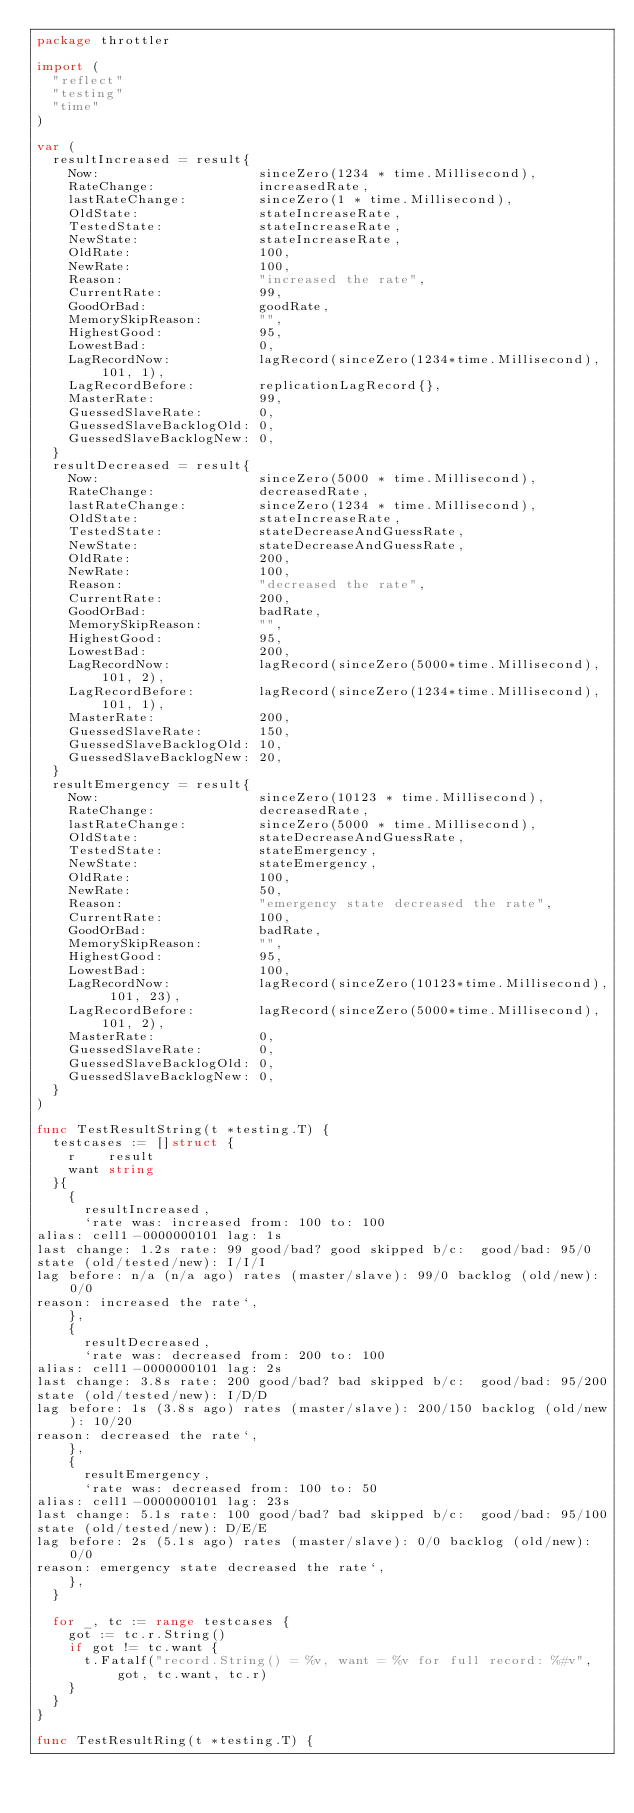<code> <loc_0><loc_0><loc_500><loc_500><_Go_>package throttler

import (
	"reflect"
	"testing"
	"time"
)

var (
	resultIncreased = result{
		Now:                    sinceZero(1234 * time.Millisecond),
		RateChange:             increasedRate,
		lastRateChange:         sinceZero(1 * time.Millisecond),
		OldState:               stateIncreaseRate,
		TestedState:            stateIncreaseRate,
		NewState:               stateIncreaseRate,
		OldRate:                100,
		NewRate:                100,
		Reason:                 "increased the rate",
		CurrentRate:            99,
		GoodOrBad:              goodRate,
		MemorySkipReason:       "",
		HighestGood:            95,
		LowestBad:              0,
		LagRecordNow:           lagRecord(sinceZero(1234*time.Millisecond), 101, 1),
		LagRecordBefore:        replicationLagRecord{},
		MasterRate:             99,
		GuessedSlaveRate:       0,
		GuessedSlaveBacklogOld: 0,
		GuessedSlaveBacklogNew: 0,
	}
	resultDecreased = result{
		Now:                    sinceZero(5000 * time.Millisecond),
		RateChange:             decreasedRate,
		lastRateChange:         sinceZero(1234 * time.Millisecond),
		OldState:               stateIncreaseRate,
		TestedState:            stateDecreaseAndGuessRate,
		NewState:               stateDecreaseAndGuessRate,
		OldRate:                200,
		NewRate:                100,
		Reason:                 "decreased the rate",
		CurrentRate:            200,
		GoodOrBad:              badRate,
		MemorySkipReason:       "",
		HighestGood:            95,
		LowestBad:              200,
		LagRecordNow:           lagRecord(sinceZero(5000*time.Millisecond), 101, 2),
		LagRecordBefore:        lagRecord(sinceZero(1234*time.Millisecond), 101, 1),
		MasterRate:             200,
		GuessedSlaveRate:       150,
		GuessedSlaveBacklogOld: 10,
		GuessedSlaveBacklogNew: 20,
	}
	resultEmergency = result{
		Now:                    sinceZero(10123 * time.Millisecond),
		RateChange:             decreasedRate,
		lastRateChange:         sinceZero(5000 * time.Millisecond),
		OldState:               stateDecreaseAndGuessRate,
		TestedState:            stateEmergency,
		NewState:               stateEmergency,
		OldRate:                100,
		NewRate:                50,
		Reason:                 "emergency state decreased the rate",
		CurrentRate:            100,
		GoodOrBad:              badRate,
		MemorySkipReason:       "",
		HighestGood:            95,
		LowestBad:              100,
		LagRecordNow:           lagRecord(sinceZero(10123*time.Millisecond), 101, 23),
		LagRecordBefore:        lagRecord(sinceZero(5000*time.Millisecond), 101, 2),
		MasterRate:             0,
		GuessedSlaveRate:       0,
		GuessedSlaveBacklogOld: 0,
		GuessedSlaveBacklogNew: 0,
	}
)

func TestResultString(t *testing.T) {
	testcases := []struct {
		r    result
		want string
	}{
		{
			resultIncreased,
			`rate was: increased from: 100 to: 100
alias: cell1-0000000101 lag: 1s
last change: 1.2s rate: 99 good/bad? good skipped b/c:  good/bad: 95/0
state (old/tested/new): I/I/I 
lag before: n/a (n/a ago) rates (master/slave): 99/0 backlog (old/new): 0/0
reason: increased the rate`,
		},
		{
			resultDecreased,
			`rate was: decreased from: 200 to: 100
alias: cell1-0000000101 lag: 2s
last change: 3.8s rate: 200 good/bad? bad skipped b/c:  good/bad: 95/200
state (old/tested/new): I/D/D 
lag before: 1s (3.8s ago) rates (master/slave): 200/150 backlog (old/new): 10/20
reason: decreased the rate`,
		},
		{
			resultEmergency,
			`rate was: decreased from: 100 to: 50
alias: cell1-0000000101 lag: 23s
last change: 5.1s rate: 100 good/bad? bad skipped b/c:  good/bad: 95/100
state (old/tested/new): D/E/E 
lag before: 2s (5.1s ago) rates (master/slave): 0/0 backlog (old/new): 0/0
reason: emergency state decreased the rate`,
		},
	}

	for _, tc := range testcases {
		got := tc.r.String()
		if got != tc.want {
			t.Fatalf("record.String() = %v, want = %v for full record: %#v", got, tc.want, tc.r)
		}
	}
}

func TestResultRing(t *testing.T) {</code> 